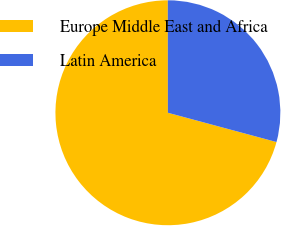<chart> <loc_0><loc_0><loc_500><loc_500><pie_chart><fcel>Europe Middle East and Africa<fcel>Latin America<nl><fcel>70.8%<fcel>29.2%<nl></chart> 